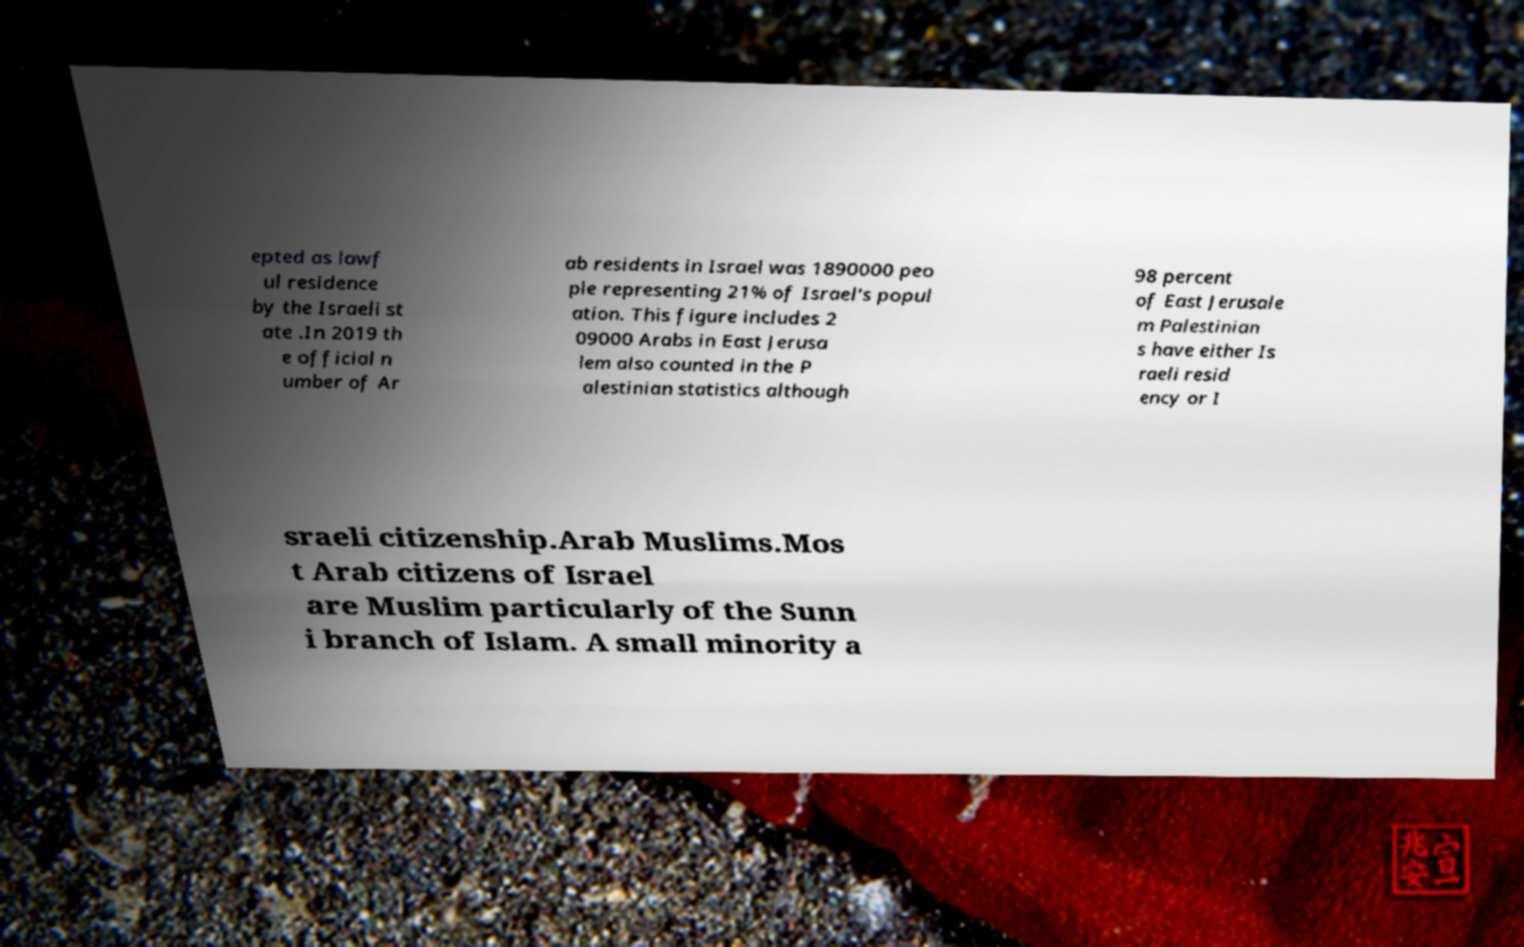What messages or text are displayed in this image? I need them in a readable, typed format. epted as lawf ul residence by the Israeli st ate .In 2019 th e official n umber of Ar ab residents in Israel was 1890000 peo ple representing 21% of Israel's popul ation. This figure includes 2 09000 Arabs in East Jerusa lem also counted in the P alestinian statistics although 98 percent of East Jerusale m Palestinian s have either Is raeli resid ency or I sraeli citizenship.Arab Muslims.Mos t Arab citizens of Israel are Muslim particularly of the Sunn i branch of Islam. A small minority a 